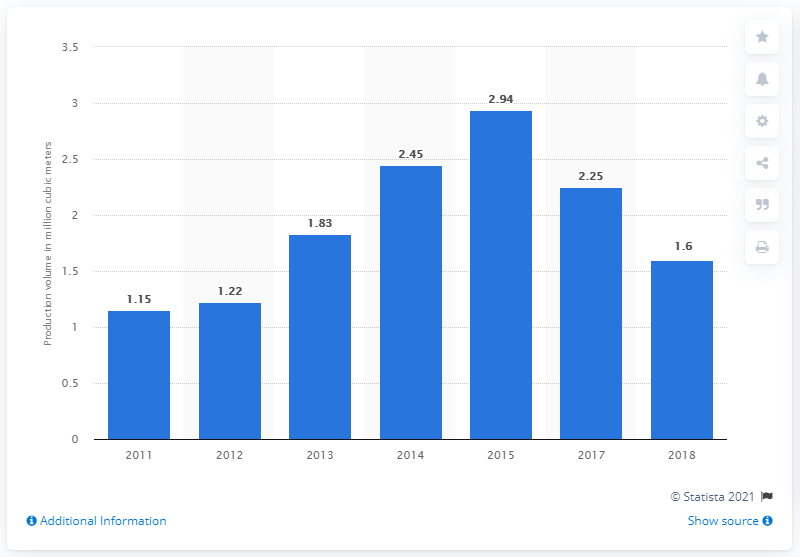Highlight a few significant elements in this photo. In 2015, a total of 2.94 cubic meters of silica sand was produced in Indonesia. In 2018, a total of 1.6 million cubic meters of silica sand was produced in Indonesia. 